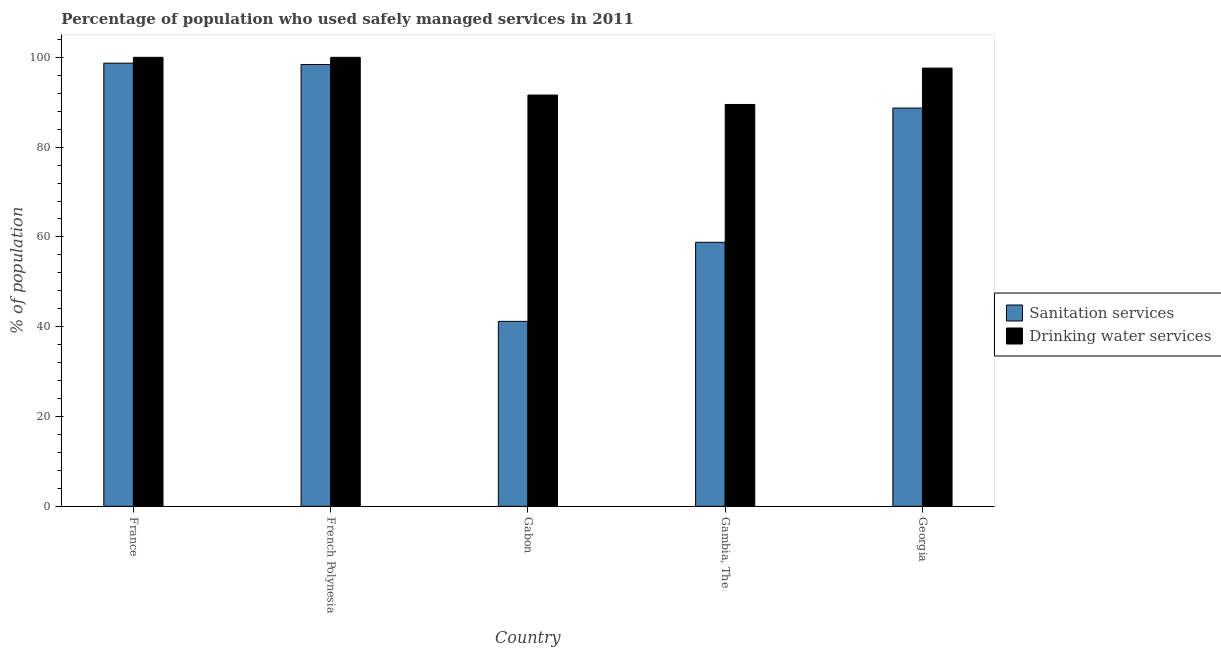Are the number of bars per tick equal to the number of legend labels?
Ensure brevity in your answer.  Yes. Are the number of bars on each tick of the X-axis equal?
Give a very brief answer. Yes. What is the label of the 2nd group of bars from the left?
Provide a short and direct response. French Polynesia. Across all countries, what is the maximum percentage of population who used sanitation services?
Your answer should be compact. 98.7. Across all countries, what is the minimum percentage of population who used sanitation services?
Make the answer very short. 41.2. In which country was the percentage of population who used sanitation services maximum?
Provide a short and direct response. France. In which country was the percentage of population who used drinking water services minimum?
Offer a very short reply. Gambia, The. What is the total percentage of population who used sanitation services in the graph?
Make the answer very short. 385.8. What is the difference between the percentage of population who used drinking water services in Georgia and the percentage of population who used sanitation services in Gabon?
Make the answer very short. 56.4. What is the average percentage of population who used drinking water services per country?
Give a very brief answer. 95.74. What is the difference between the percentage of population who used sanitation services and percentage of population who used drinking water services in Gabon?
Your answer should be compact. -50.4. What is the ratio of the percentage of population who used sanitation services in France to that in Gambia, The?
Your response must be concise. 1.68. Is the percentage of population who used drinking water services in French Polynesia less than that in Gambia, The?
Your response must be concise. No. What is the difference between the highest and the lowest percentage of population who used sanitation services?
Ensure brevity in your answer.  57.5. In how many countries, is the percentage of population who used sanitation services greater than the average percentage of population who used sanitation services taken over all countries?
Offer a terse response. 3. Is the sum of the percentage of population who used sanitation services in France and Georgia greater than the maximum percentage of population who used drinking water services across all countries?
Provide a succinct answer. Yes. What does the 2nd bar from the left in French Polynesia represents?
Your answer should be compact. Drinking water services. What does the 1st bar from the right in Gabon represents?
Keep it short and to the point. Drinking water services. What is the difference between two consecutive major ticks on the Y-axis?
Your response must be concise. 20. Are the values on the major ticks of Y-axis written in scientific E-notation?
Your answer should be very brief. No. Where does the legend appear in the graph?
Keep it short and to the point. Center right. What is the title of the graph?
Your response must be concise. Percentage of population who used safely managed services in 2011. What is the label or title of the X-axis?
Your answer should be very brief. Country. What is the label or title of the Y-axis?
Provide a succinct answer. % of population. What is the % of population of Sanitation services in France?
Offer a very short reply. 98.7. What is the % of population in Drinking water services in France?
Your response must be concise. 100. What is the % of population in Sanitation services in French Polynesia?
Provide a succinct answer. 98.4. What is the % of population in Sanitation services in Gabon?
Give a very brief answer. 41.2. What is the % of population of Drinking water services in Gabon?
Give a very brief answer. 91.6. What is the % of population in Sanitation services in Gambia, The?
Make the answer very short. 58.8. What is the % of population of Drinking water services in Gambia, The?
Offer a terse response. 89.5. What is the % of population in Sanitation services in Georgia?
Provide a succinct answer. 88.7. What is the % of population of Drinking water services in Georgia?
Offer a terse response. 97.6. Across all countries, what is the maximum % of population of Sanitation services?
Provide a short and direct response. 98.7. Across all countries, what is the minimum % of population in Sanitation services?
Your answer should be compact. 41.2. Across all countries, what is the minimum % of population of Drinking water services?
Keep it short and to the point. 89.5. What is the total % of population in Sanitation services in the graph?
Your answer should be compact. 385.8. What is the total % of population in Drinking water services in the graph?
Keep it short and to the point. 478.7. What is the difference between the % of population of Drinking water services in France and that in French Polynesia?
Offer a very short reply. 0. What is the difference between the % of population of Sanitation services in France and that in Gabon?
Keep it short and to the point. 57.5. What is the difference between the % of population of Drinking water services in France and that in Gabon?
Provide a succinct answer. 8.4. What is the difference between the % of population in Sanitation services in France and that in Gambia, The?
Your answer should be very brief. 39.9. What is the difference between the % of population of Drinking water services in France and that in Georgia?
Your response must be concise. 2.4. What is the difference between the % of population in Sanitation services in French Polynesia and that in Gabon?
Offer a very short reply. 57.2. What is the difference between the % of population of Sanitation services in French Polynesia and that in Gambia, The?
Ensure brevity in your answer.  39.6. What is the difference between the % of population in Drinking water services in French Polynesia and that in Gambia, The?
Provide a succinct answer. 10.5. What is the difference between the % of population in Sanitation services in French Polynesia and that in Georgia?
Give a very brief answer. 9.7. What is the difference between the % of population of Drinking water services in French Polynesia and that in Georgia?
Provide a short and direct response. 2.4. What is the difference between the % of population in Sanitation services in Gabon and that in Gambia, The?
Offer a very short reply. -17.6. What is the difference between the % of population of Drinking water services in Gabon and that in Gambia, The?
Give a very brief answer. 2.1. What is the difference between the % of population in Sanitation services in Gabon and that in Georgia?
Make the answer very short. -47.5. What is the difference between the % of population of Sanitation services in Gambia, The and that in Georgia?
Make the answer very short. -29.9. What is the difference between the % of population of Sanitation services in French Polynesia and the % of population of Drinking water services in Gabon?
Your answer should be very brief. 6.8. What is the difference between the % of population of Sanitation services in French Polynesia and the % of population of Drinking water services in Georgia?
Your response must be concise. 0.8. What is the difference between the % of population of Sanitation services in Gabon and the % of population of Drinking water services in Gambia, The?
Your response must be concise. -48.3. What is the difference between the % of population of Sanitation services in Gabon and the % of population of Drinking water services in Georgia?
Make the answer very short. -56.4. What is the difference between the % of population in Sanitation services in Gambia, The and the % of population in Drinking water services in Georgia?
Make the answer very short. -38.8. What is the average % of population in Sanitation services per country?
Your response must be concise. 77.16. What is the average % of population of Drinking water services per country?
Offer a terse response. 95.74. What is the difference between the % of population in Sanitation services and % of population in Drinking water services in France?
Make the answer very short. -1.3. What is the difference between the % of population of Sanitation services and % of population of Drinking water services in Gabon?
Offer a very short reply. -50.4. What is the difference between the % of population in Sanitation services and % of population in Drinking water services in Gambia, The?
Make the answer very short. -30.7. What is the ratio of the % of population in Sanitation services in France to that in French Polynesia?
Your response must be concise. 1. What is the ratio of the % of population in Drinking water services in France to that in French Polynesia?
Keep it short and to the point. 1. What is the ratio of the % of population of Sanitation services in France to that in Gabon?
Ensure brevity in your answer.  2.4. What is the ratio of the % of population in Drinking water services in France to that in Gabon?
Make the answer very short. 1.09. What is the ratio of the % of population of Sanitation services in France to that in Gambia, The?
Your response must be concise. 1.68. What is the ratio of the % of population of Drinking water services in France to that in Gambia, The?
Your answer should be compact. 1.12. What is the ratio of the % of population in Sanitation services in France to that in Georgia?
Provide a succinct answer. 1.11. What is the ratio of the % of population in Drinking water services in France to that in Georgia?
Provide a short and direct response. 1.02. What is the ratio of the % of population in Sanitation services in French Polynesia to that in Gabon?
Offer a very short reply. 2.39. What is the ratio of the % of population of Drinking water services in French Polynesia to that in Gabon?
Give a very brief answer. 1.09. What is the ratio of the % of population of Sanitation services in French Polynesia to that in Gambia, The?
Offer a terse response. 1.67. What is the ratio of the % of population in Drinking water services in French Polynesia to that in Gambia, The?
Your response must be concise. 1.12. What is the ratio of the % of population of Sanitation services in French Polynesia to that in Georgia?
Your answer should be very brief. 1.11. What is the ratio of the % of population of Drinking water services in French Polynesia to that in Georgia?
Provide a short and direct response. 1.02. What is the ratio of the % of population in Sanitation services in Gabon to that in Gambia, The?
Offer a very short reply. 0.7. What is the ratio of the % of population in Drinking water services in Gabon to that in Gambia, The?
Give a very brief answer. 1.02. What is the ratio of the % of population in Sanitation services in Gabon to that in Georgia?
Offer a very short reply. 0.46. What is the ratio of the % of population of Drinking water services in Gabon to that in Georgia?
Offer a terse response. 0.94. What is the ratio of the % of population in Sanitation services in Gambia, The to that in Georgia?
Provide a short and direct response. 0.66. What is the ratio of the % of population of Drinking water services in Gambia, The to that in Georgia?
Ensure brevity in your answer.  0.92. What is the difference between the highest and the lowest % of population of Sanitation services?
Ensure brevity in your answer.  57.5. 